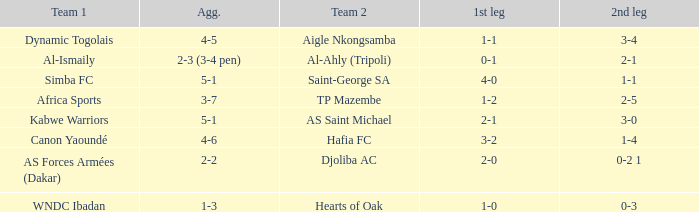Which team competed against al-ismaily (team 1)? Al-Ahly (Tripoli). 